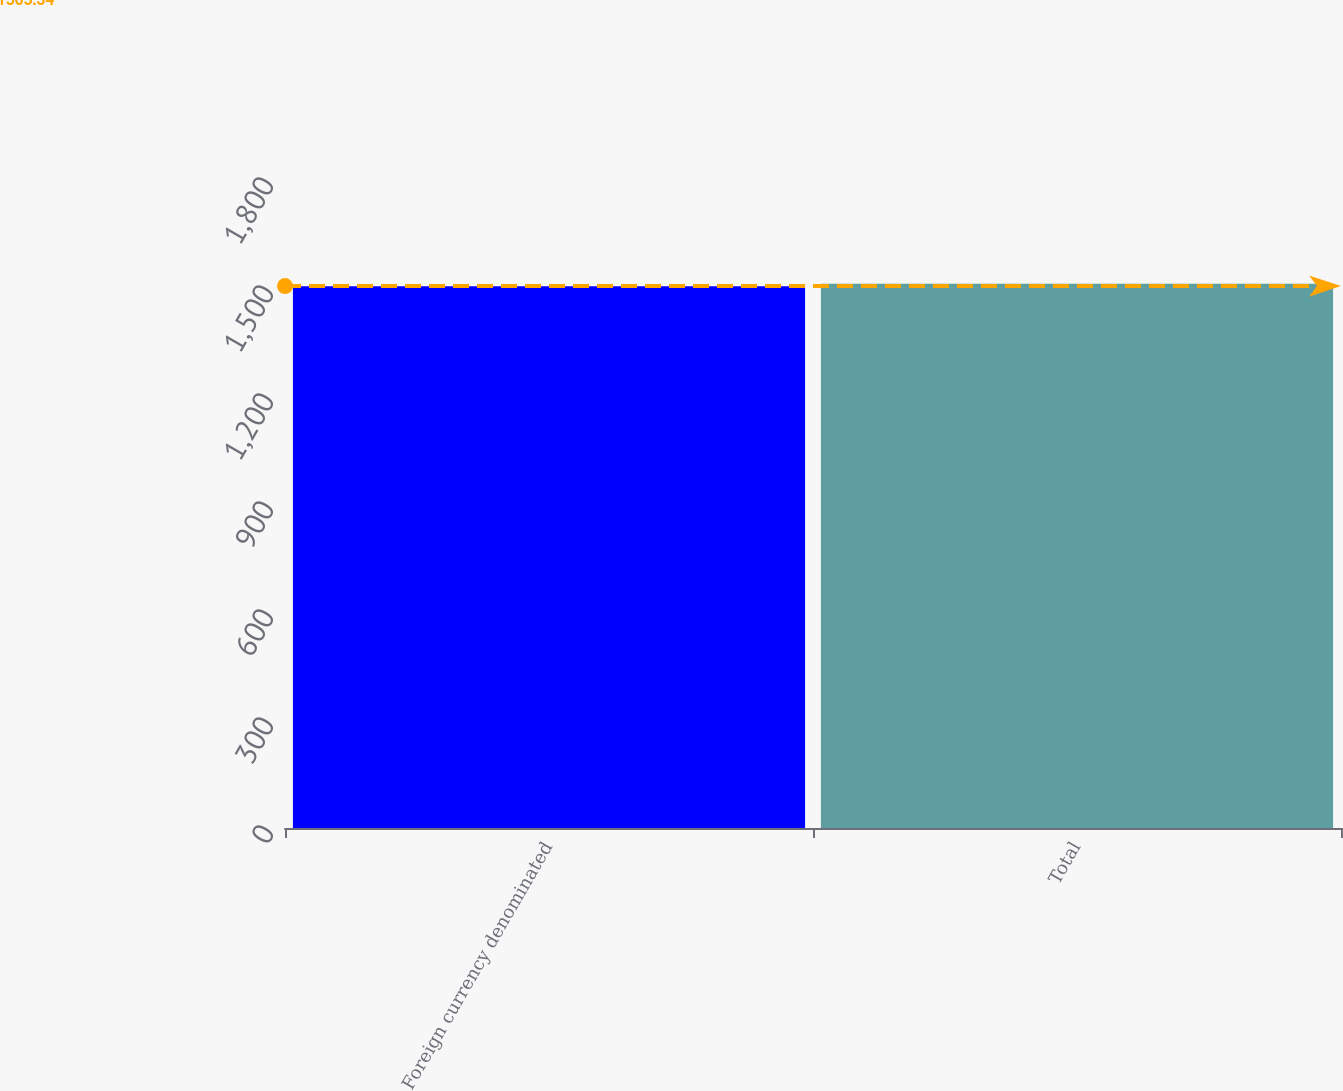<chart> <loc_0><loc_0><loc_500><loc_500><bar_chart><fcel>Foreign currency denominated<fcel>Total<nl><fcel>1505<fcel>1512<nl></chart> 